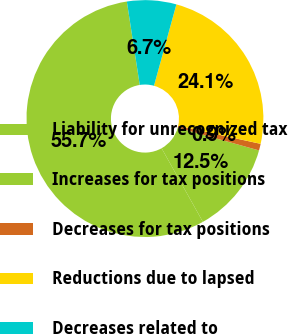Convert chart to OTSL. <chart><loc_0><loc_0><loc_500><loc_500><pie_chart><fcel>Liability for unrecognized tax<fcel>Increases for tax positions<fcel>Decreases for tax positions<fcel>Reductions due to lapsed<fcel>Decreases related to<nl><fcel>55.7%<fcel>12.53%<fcel>0.91%<fcel>24.15%<fcel>6.72%<nl></chart> 